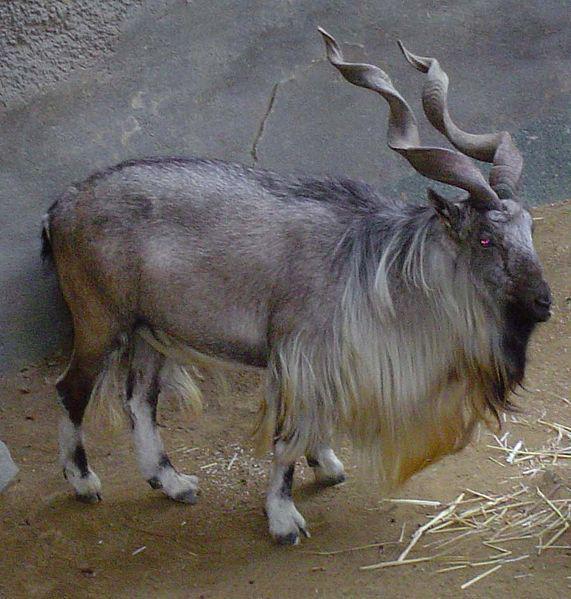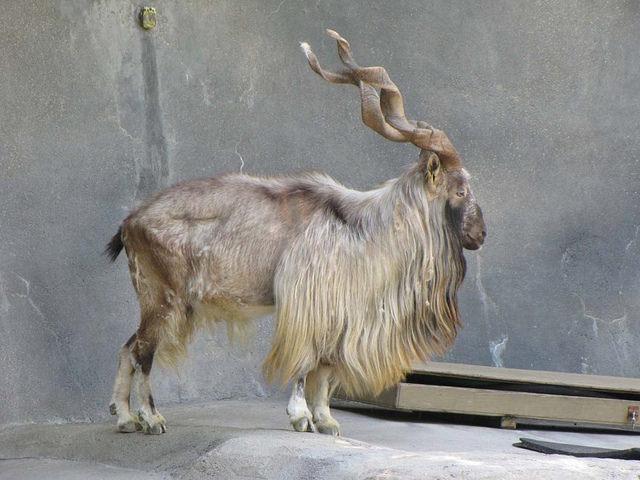The first image is the image on the left, the second image is the image on the right. Considering the images on both sides, is "Each image contains one horned animal in front of a wall of rock, and the animals in the left and right images face the same way and have very similar body positions." valid? Answer yes or no. Yes. The first image is the image on the left, the second image is the image on the right. Examine the images to the left and right. Is the description "The left and right image contains the same number of goats facing the same direction." accurate? Answer yes or no. Yes. 